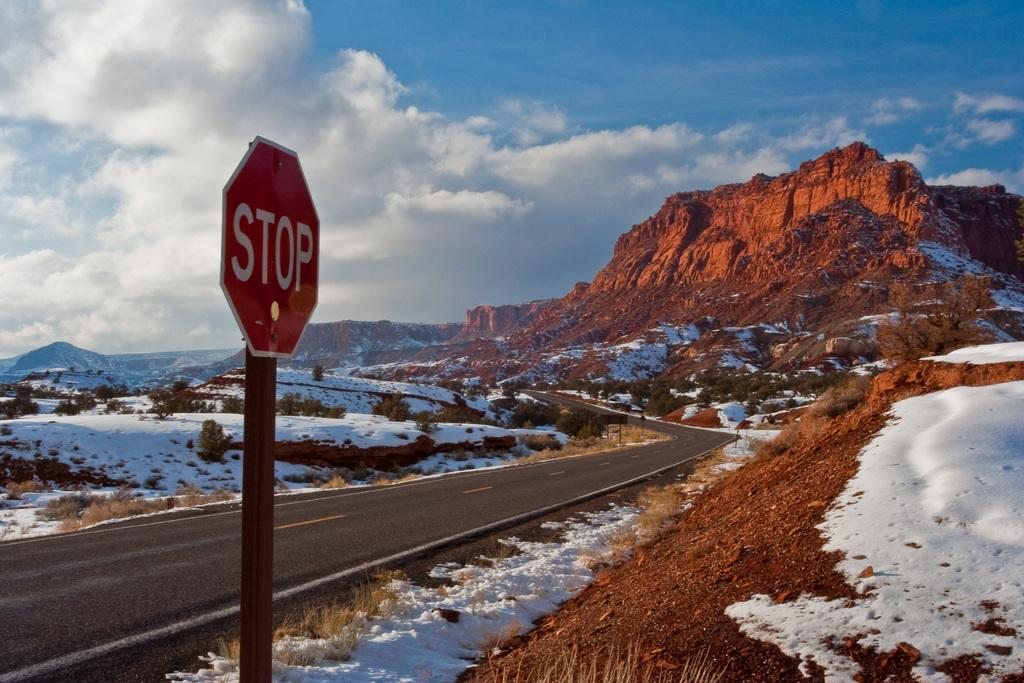<image>
Share a concise interpretation of the image provided. the word stop that is on a sign 